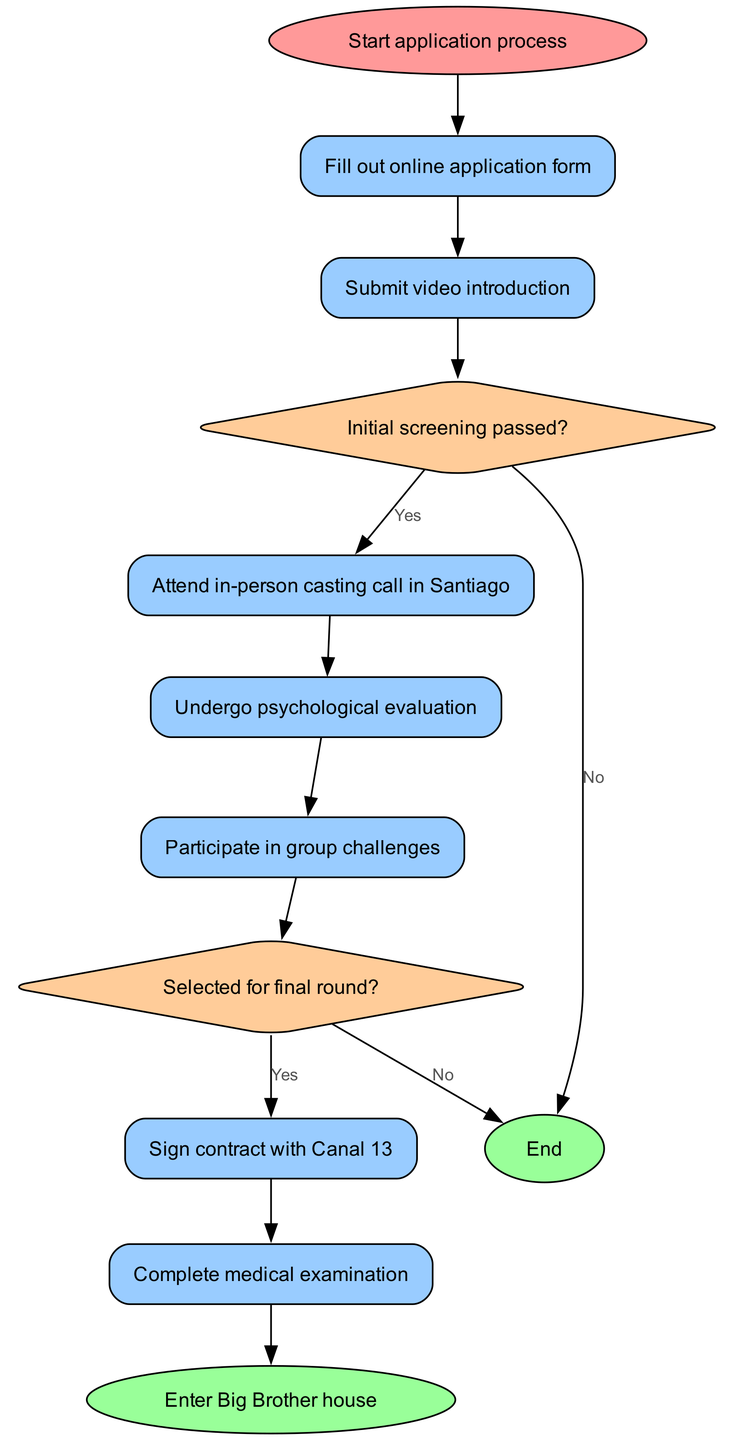What is the first step in the audition process? The first step in the diagram is "Start application process," which indicates the beginning of the journey for a contestant looking to join the show.
Answer: Start application process How many decision nodes are in the diagram? There are two decision nodes present in the diagram: "Initial screening passed?" and "Selected for final round?" Each of these nodes checks for specific conditions in the process.
Answer: 2 What action follows after submitting the video introduction? The action that follows is "Initial screening passed?" This decision point determines if the candidate moves forward in the process.
Answer: Initial screening passed? If a candidate does not pass the initial screening, what is the next step? If the initial screening is not passed, the process leads directly to the end of the application as indicated by an edge labeled "No". No further actions are taken.
Answer: End What is required to participate in the final round? A contestant must be "Selected for final round?" to participate. If they are selected, they can proceed to sign a contract with Canal 13.
Answer: Sign contract with Canal 13 How many actions are there before entering the Big Brother house? There are five actions leading up to entering the Big Brother house: filling out the application form, submitting a video, attending the casting call, signing a contract, and completing a medical examination.
Answer: 5 What are the two outcomes from the decision "Selected for final round?" The two outcomes are either to "Sign contract with Canal 13" if selected or to "End" if not selected. This shows the bifurcation based on the decision made.
Answer: Sign contract with Canal 13, End What indicates the end of the contestant's journey? The end of the journey is indicated by the node labeled "Enter Big Brother house," which signifies that the contestant has successfully completed all prior requirements.
Answer: Enter Big Brother house What is the final action that happens just before entering the Big Brother house? The final action before entering is "Complete medical examination," which is a crucial step to ensure contestants are fit for the show.
Answer: Complete medical examination 